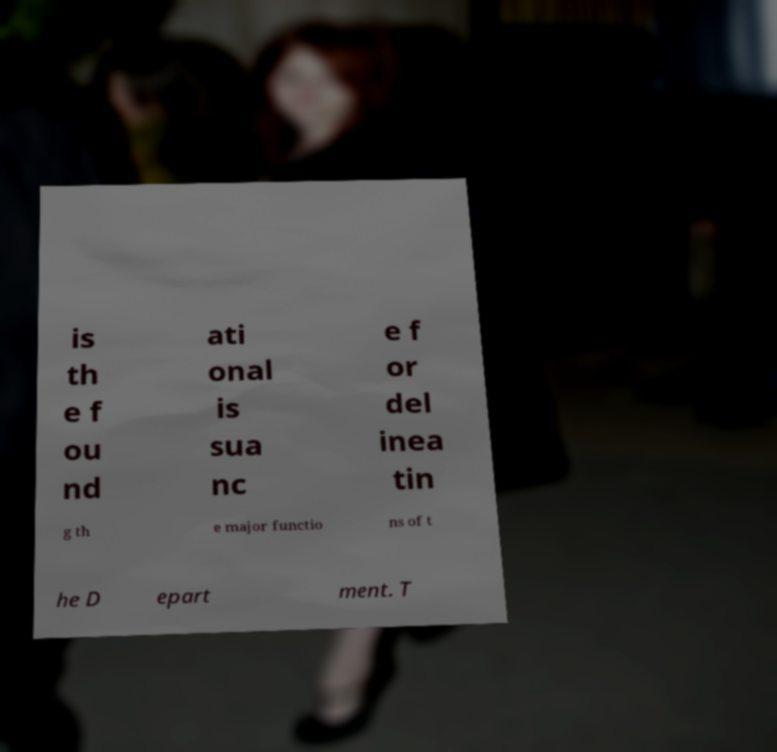Please identify and transcribe the text found in this image. is th e f ou nd ati onal is sua nc e f or del inea tin g th e major functio ns of t he D epart ment. T 